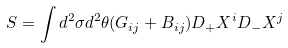<formula> <loc_0><loc_0><loc_500><loc_500>S = \int d ^ { 2 } \sigma d ^ { 2 } \theta ( G _ { i j } + B _ { i j } ) D _ { + } X ^ { i } D _ { - } X ^ { j }</formula> 